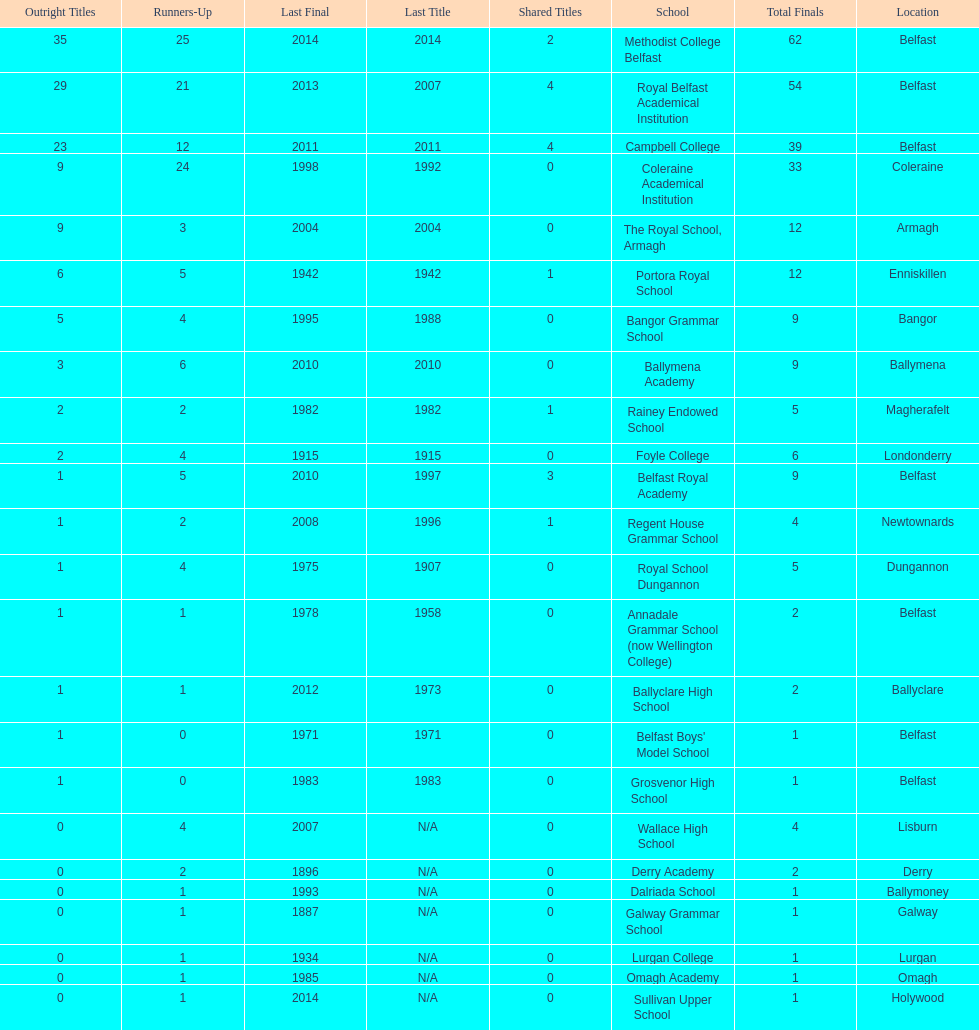Which schools have the largest number of shared titles? Royal Belfast Academical Institution, Campbell College. 